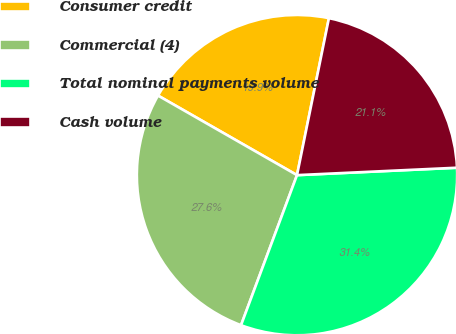<chart> <loc_0><loc_0><loc_500><loc_500><pie_chart><fcel>Consumer credit<fcel>Commercial (4)<fcel>Total nominal payments volume<fcel>Cash volume<nl><fcel>19.92%<fcel>27.59%<fcel>31.42%<fcel>21.07%<nl></chart> 